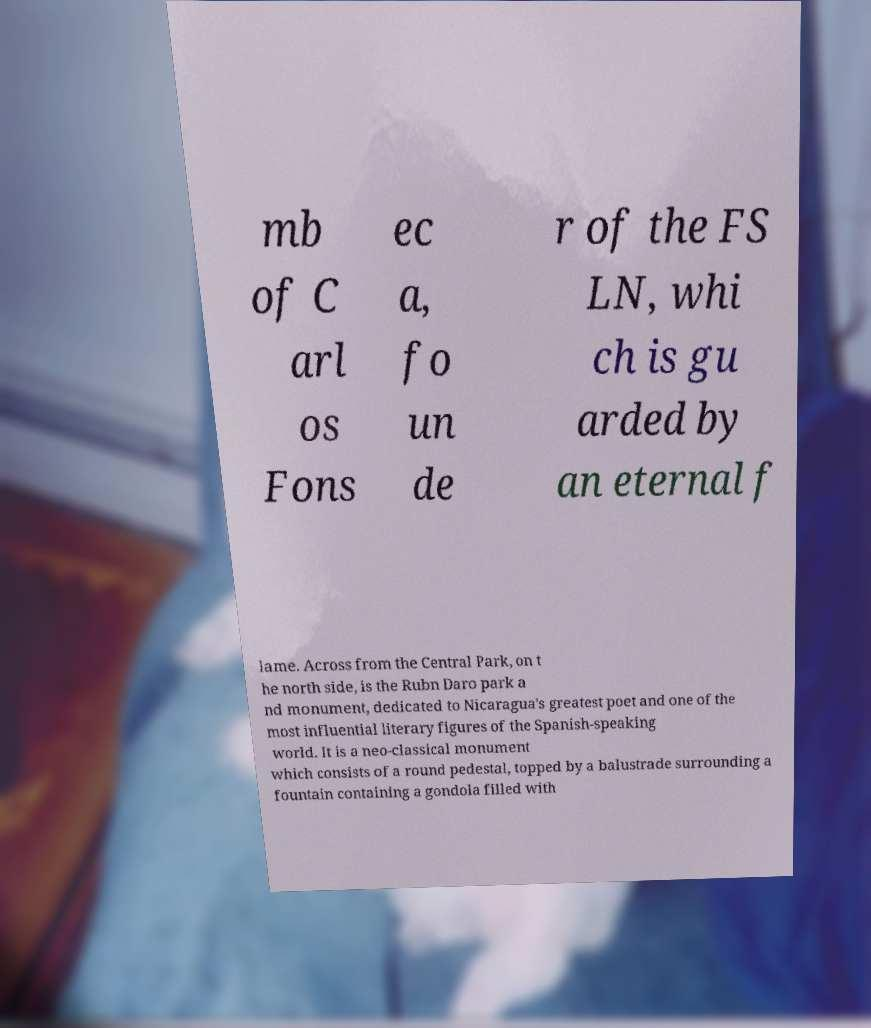Can you accurately transcribe the text from the provided image for me? mb of C arl os Fons ec a, fo un de r of the FS LN, whi ch is gu arded by an eternal f lame. Across from the Central Park, on t he north side, is the Rubn Daro park a nd monument, dedicated to Nicaragua's greatest poet and one of the most influential literary figures of the Spanish-speaking world. It is a neo-classical monument which consists of a round pedestal, topped by a balustrade surrounding a fountain containing a gondola filled with 